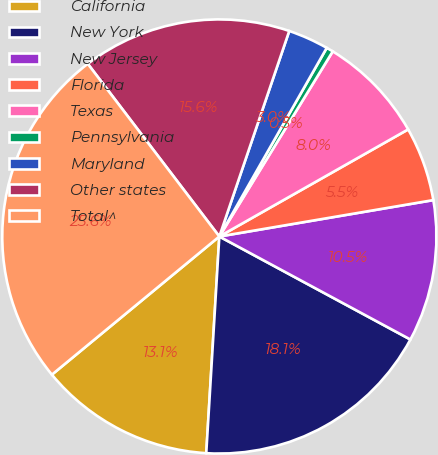Convert chart to OTSL. <chart><loc_0><loc_0><loc_500><loc_500><pie_chart><fcel>California<fcel>New York<fcel>New Jersey<fcel>Florida<fcel>Texas<fcel>Pennsylvania<fcel>Maryland<fcel>Other states<fcel>Total^<nl><fcel>13.06%<fcel>18.09%<fcel>10.55%<fcel>5.53%<fcel>8.04%<fcel>0.51%<fcel>3.02%<fcel>15.58%<fcel>25.62%<nl></chart> 